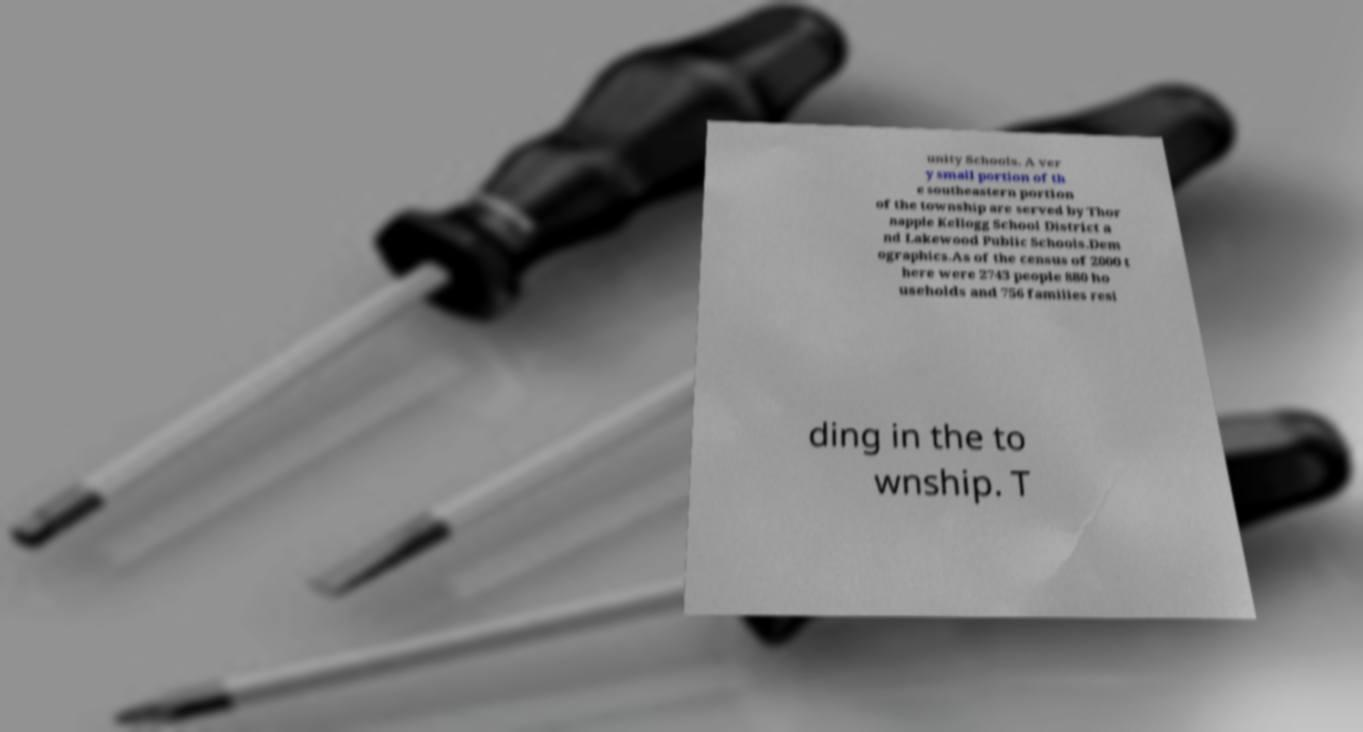Please read and relay the text visible in this image. What does it say? unity Schools. A ver y small portion of th e southeastern portion of the township are served by Thor napple Kellogg School District a nd Lakewood Public Schools.Dem ographics.As of the census of 2000 t here were 2743 people 880 ho useholds and 756 families resi ding in the to wnship. T 